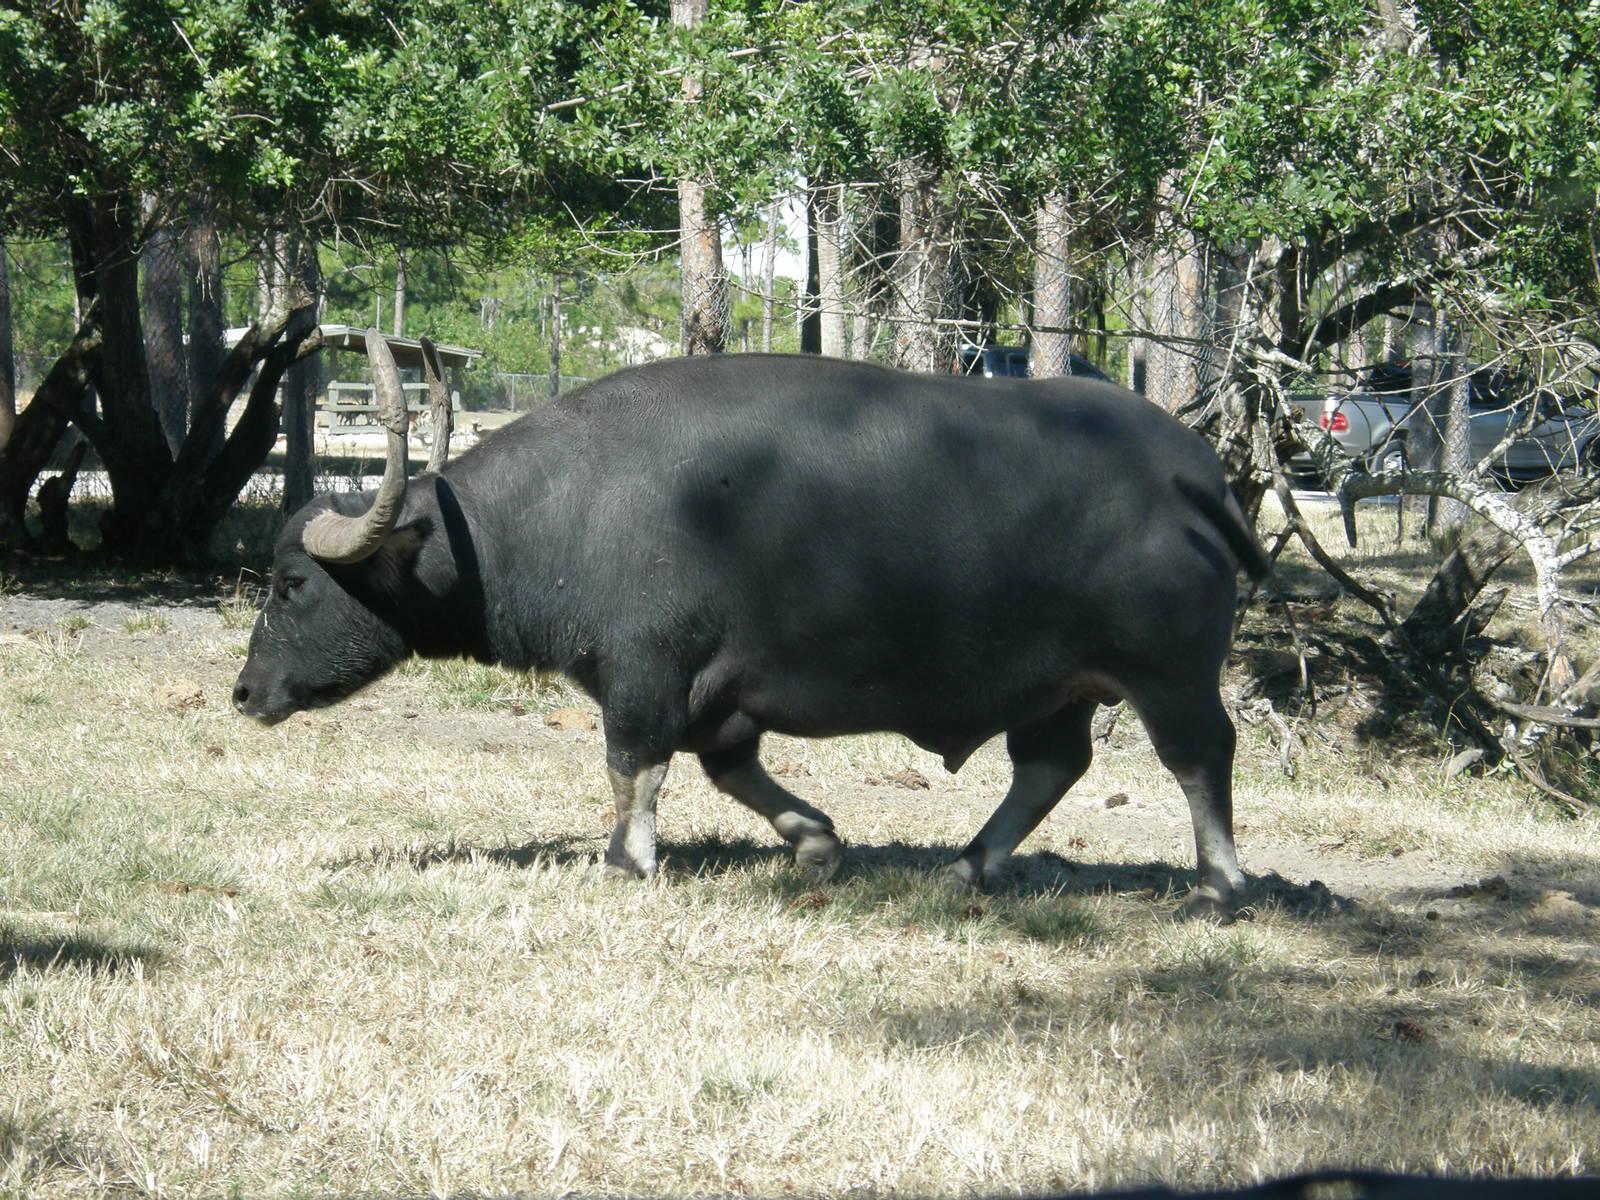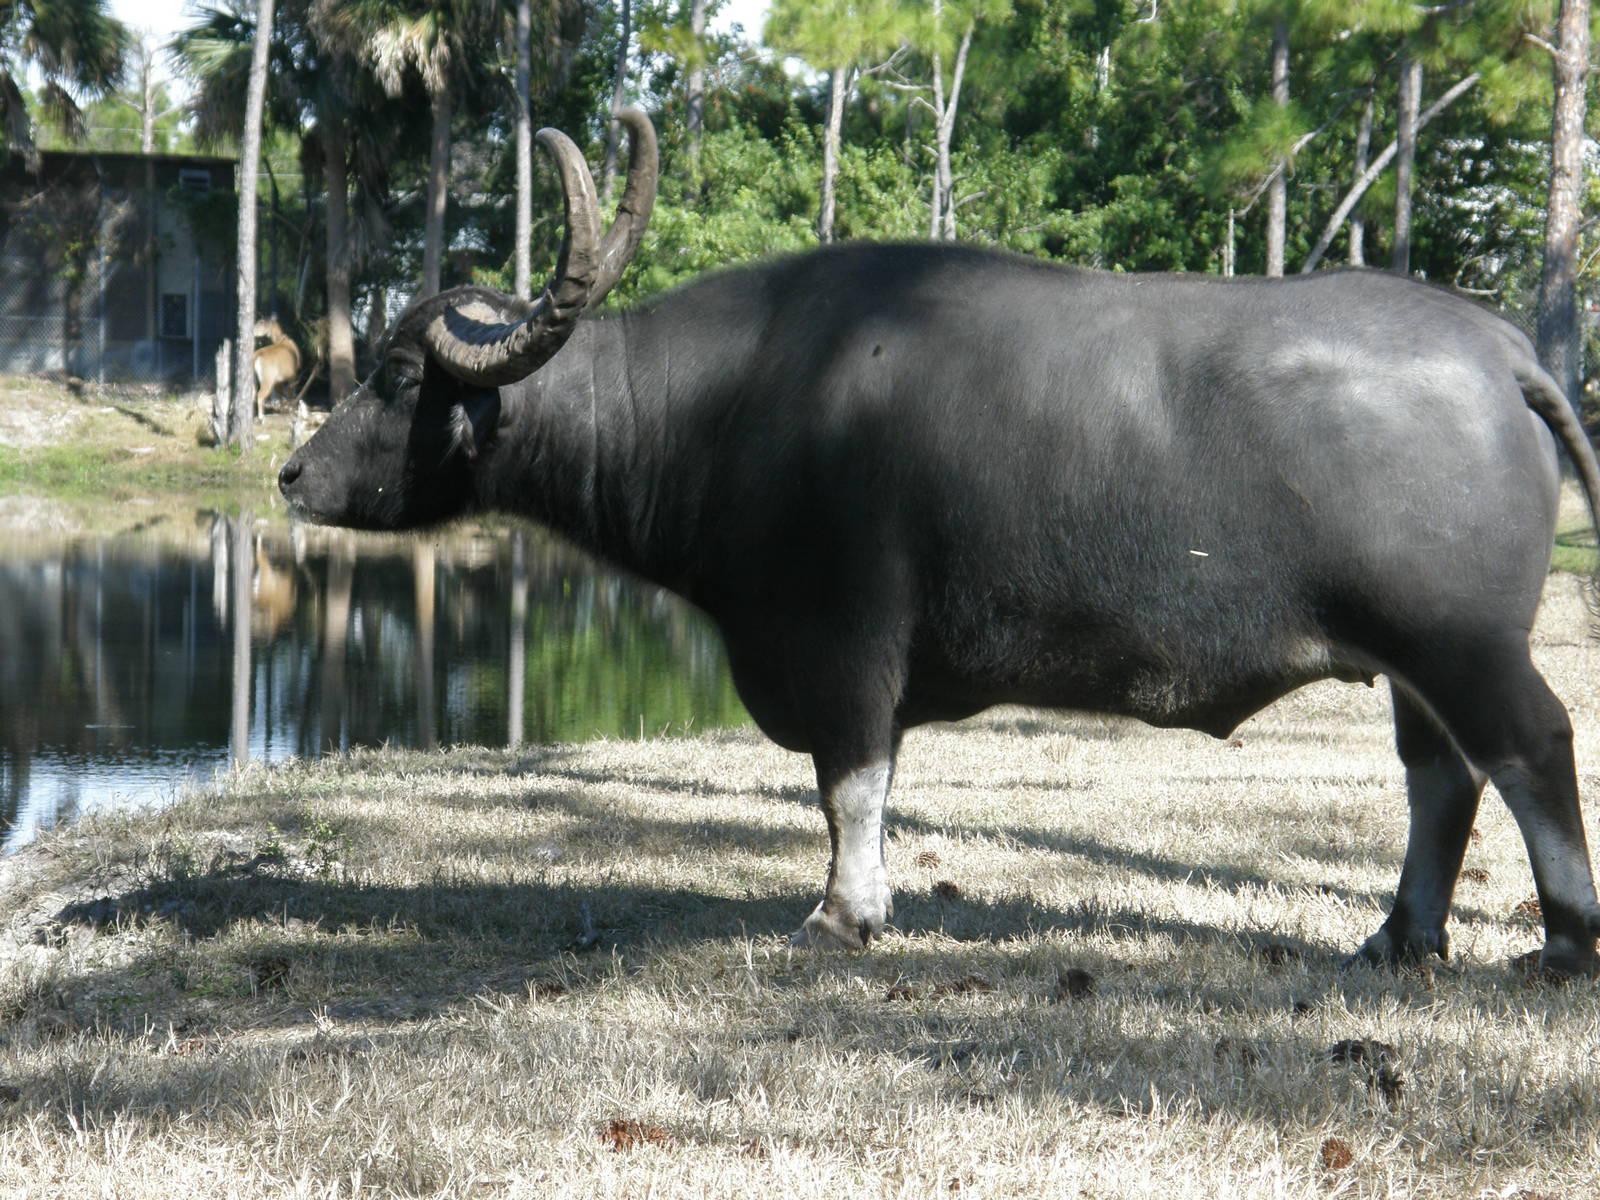The first image is the image on the left, the second image is the image on the right. Analyze the images presented: Is the assertion "There are two bison-like creatures only." valid? Answer yes or no. Yes. 